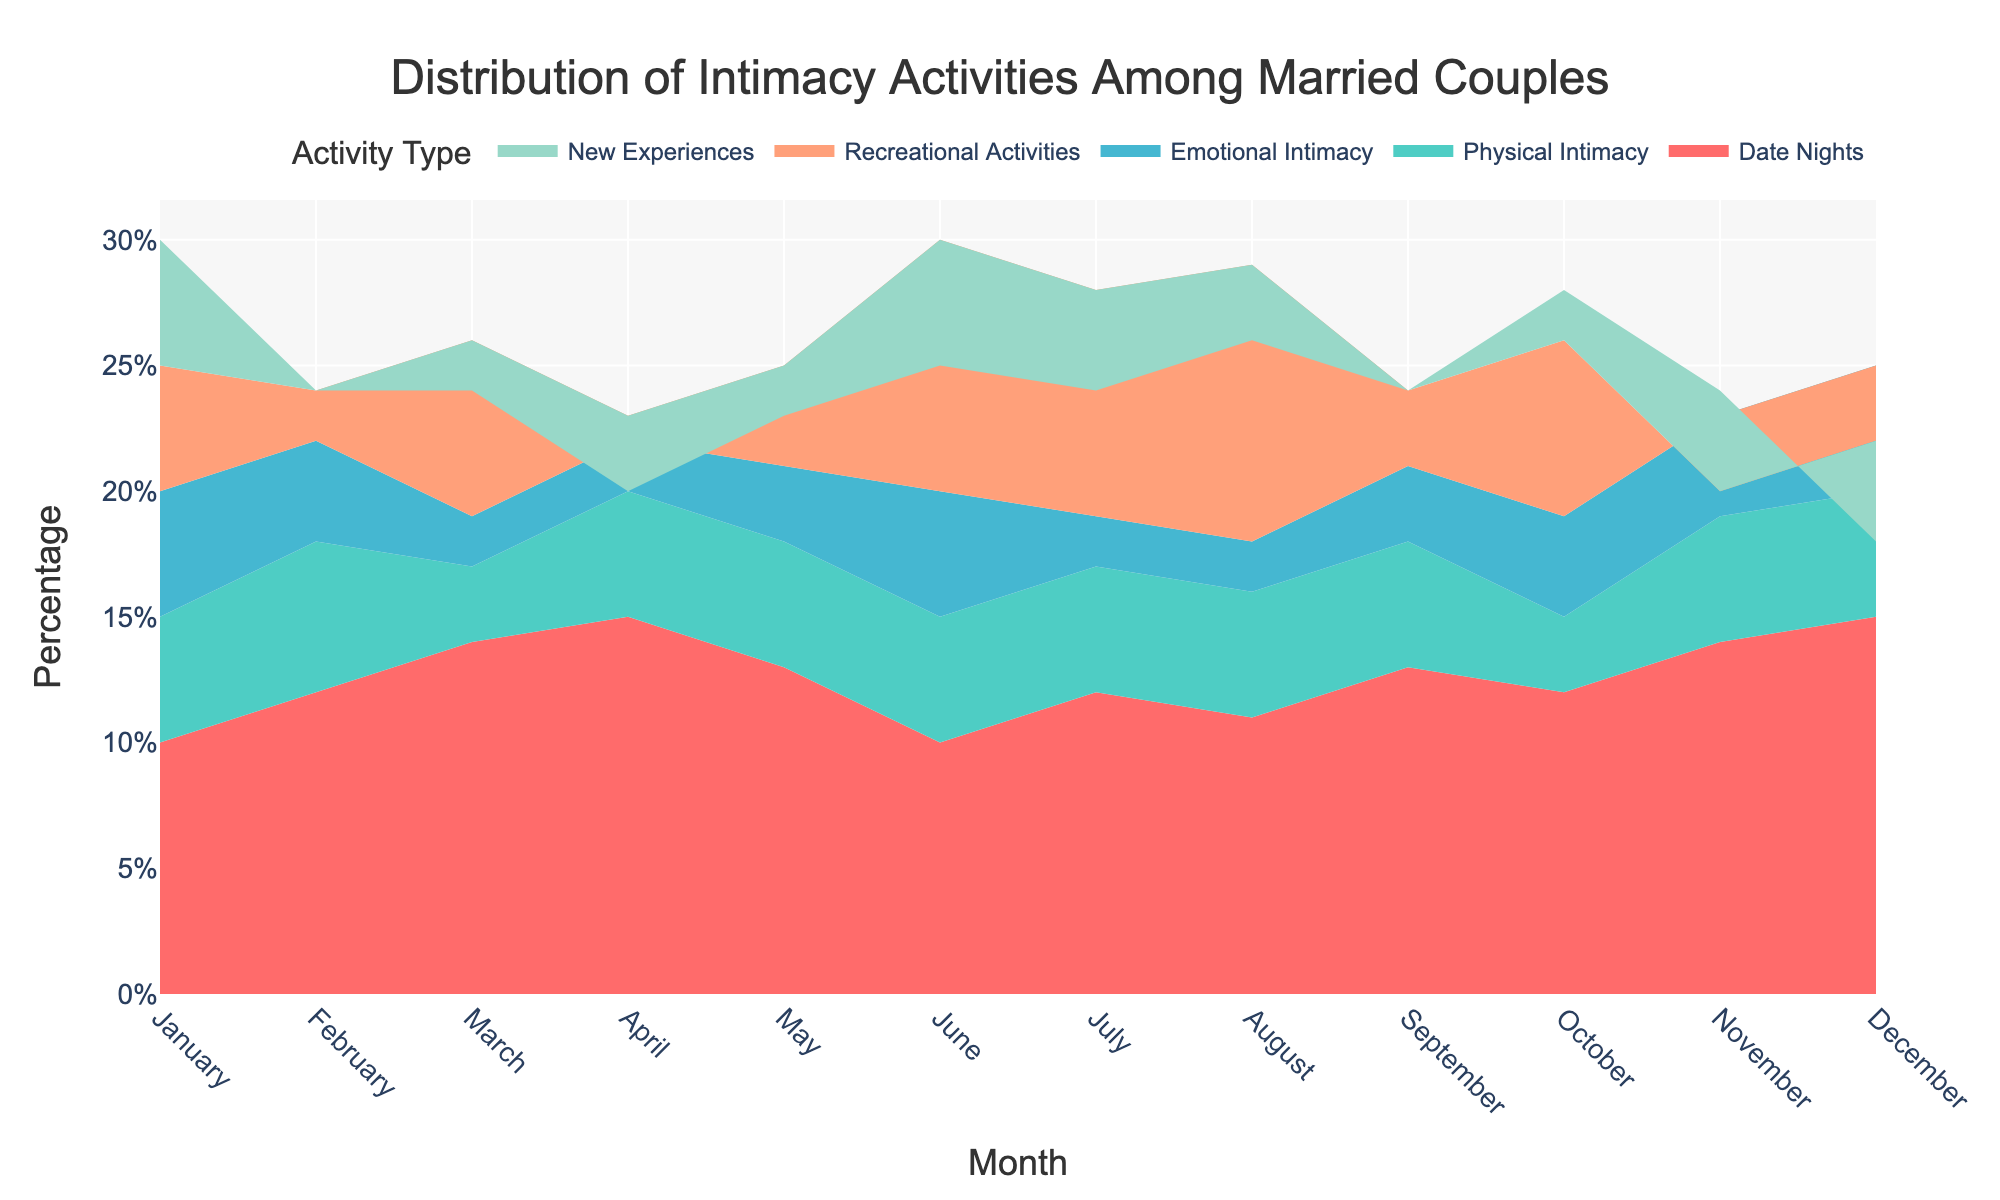What is the title of the chart? The title of the chart is usually located at the top center of the figure.
Answer: Distribution of Intimacy Activities Among Married Couples Which type of intimacy activity shows the highest percentage in January? From the stacked area section corresponding to January, observe the height of each segment. The highest percentage is the segment with the greatest height.
Answer: New Experiences In which month is the percentage of Emotional Intimacy the highest? Look for the segment corresponding to Emotional Intimacy across all months and identify the month where this segment reaches its highest percentage.
Answer: December What is the combined percentage of Physical Intimacy and Recreational Activities in June? Identify the segments for Physical Intimacy and Recreational Activities in June and add their percentages.
Answer: 45% Which month sees the highest percentage engagement in Recreational Activities? Compare the segments allocated to Recreational Activities across all months to determine which column has the highest segment for Recreational Activities.
Answer: June Is there any month where Date Nights is consistently the highest category? Examine the segments of Date Nights for each month and determine if there's any month where Date Nights are the largest segment compared to others.
Answer: No Which activity shows the least variation in percentage distribution across all months? Observe the segments of all activities and identify which one has segments most consistent in height month-to-month.
Answer: Physical Intimacy How does the percentage of New Experiences change from May to October? Observe the segment for New Experiences from May to October and note whether the segment increases, decreases, or remains stable.
Answer: Decreases What is the general trend for Emotional Intimacy from January to December? Track the segment percentage for Emotional Intimacy from January to December to determine if it increases, decreases, or remains stable.
Answer: Increases Which two months have the closest percentage for Date Nights? Compare the segments for Date Nights across all months to find two months where these segments are nearly the same in height.
Answer: February and July 